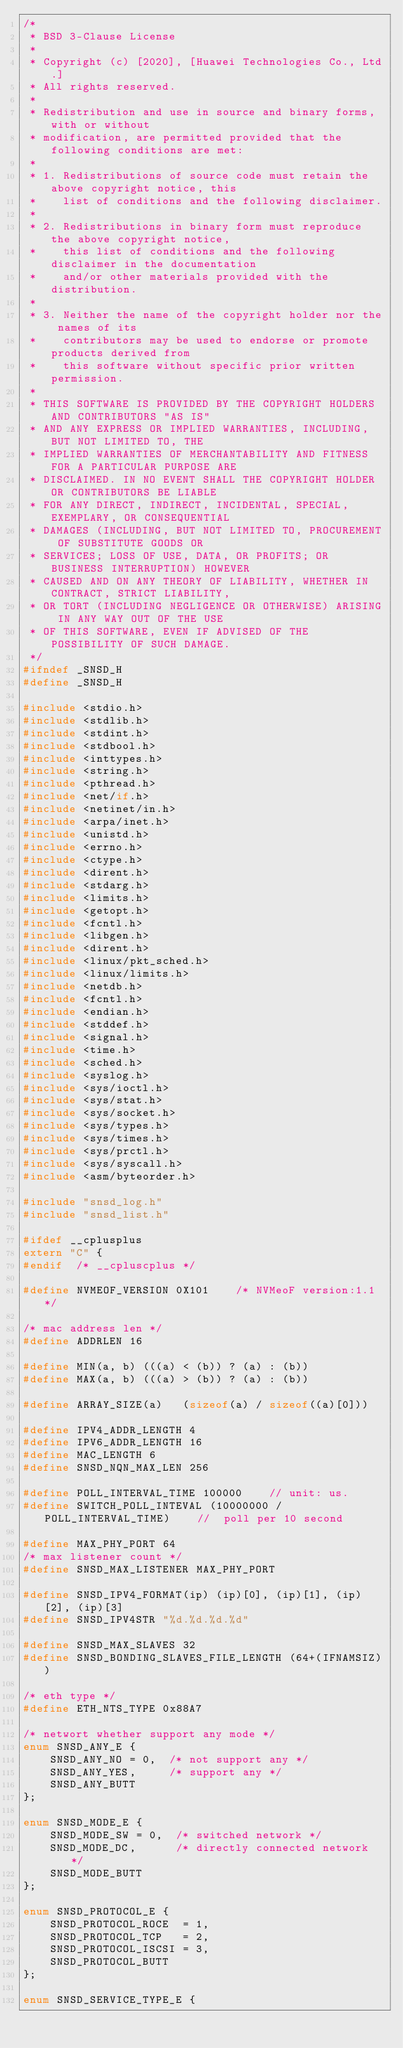<code> <loc_0><loc_0><loc_500><loc_500><_C_>/*
 * BSD 3-Clause License
 * 
 * Copyright (c) [2020], [Huawei Technologies Co., Ltd.]
 * All rights reserved.
 * 
 * Redistribution and use in source and binary forms, with or without
 * modification, are permitted provided that the following conditions are met:
 * 
 * 1. Redistributions of source code must retain the above copyright notice, this
 *    list of conditions and the following disclaimer.
 * 
 * 2. Redistributions in binary form must reproduce the above copyright notice,
 *    this list of conditions and the following disclaimer in the documentation
 *    and/or other materials provided with the distribution.
 * 
 * 3. Neither the name of the copyright holder nor the names of its
 *    contributors may be used to endorse or promote products derived from
 *    this software without specific prior written permission.
 *
 * THIS SOFTWARE IS PROVIDED BY THE COPYRIGHT HOLDERS AND CONTRIBUTORS "AS IS"
 * AND ANY EXPRESS OR IMPLIED WARRANTIES, INCLUDING, BUT NOT LIMITED TO, THE
 * IMPLIED WARRANTIES OF MERCHANTABILITY AND FITNESS FOR A PARTICULAR PURPOSE ARE
 * DISCLAIMED. IN NO EVENT SHALL THE COPYRIGHT HOLDER OR CONTRIBUTORS BE LIABLE
 * FOR ANY DIRECT, INDIRECT, INCIDENTAL, SPECIAL, EXEMPLARY, OR CONSEQUENTIAL
 * DAMAGES (INCLUDING, BUT NOT LIMITED TO, PROCUREMENT OF SUBSTITUTE GOODS OR
 * SERVICES; LOSS OF USE, DATA, OR PROFITS; OR BUSINESS INTERRUPTION) HOWEVER
 * CAUSED AND ON ANY THEORY OF LIABILITY, WHETHER IN CONTRACT, STRICT LIABILITY,
 * OR TORT (INCLUDING NEGLIGENCE OR OTHERWISE) ARISING IN ANY WAY OUT OF THE USE
 * OF THIS SOFTWARE, EVEN IF ADVISED OF THE POSSIBILITY OF SUCH DAMAGE.
 */
#ifndef _SNSD_H
#define _SNSD_H

#include <stdio.h>
#include <stdlib.h>
#include <stdint.h>
#include <stdbool.h>
#include <inttypes.h>
#include <string.h>
#include <pthread.h>
#include <net/if.h>  
#include <netinet/in.h>
#include <arpa/inet.h>
#include <unistd.h>
#include <errno.h>
#include <ctype.h>
#include <dirent.h>
#include <stdarg.h>
#include <limits.h>
#include <getopt.h>
#include <fcntl.h>
#include <libgen.h>
#include <dirent.h>
#include <linux/pkt_sched.h>
#include <linux/limits.h>
#include <netdb.h>
#include <fcntl.h>
#include <endian.h>
#include <stddef.h>
#include <signal.h>
#include <time.h>
#include <sched.h>
#include <syslog.h>
#include <sys/ioctl.h>
#include <sys/stat.h>
#include <sys/socket.h>
#include <sys/types.h>
#include <sys/times.h>
#include <sys/prctl.h>
#include <sys/syscall.h>
#include <asm/byteorder.h>

#include "snsd_log.h"
#include "snsd_list.h"

#ifdef __cplusplus
extern "C" {
#endif  /* __cpluscplus */

#define NVMEOF_VERSION 0X101    /* NVMeoF version:1.1 */

/* mac address len */
#define ADDRLEN 16

#define MIN(a, b) (((a) < (b)) ? (a) : (b))
#define MAX(a, b) (((a) > (b)) ? (a) : (b))

#define ARRAY_SIZE(a)   (sizeof(a) / sizeof((a)[0]))

#define IPV4_ADDR_LENGTH 4
#define IPV6_ADDR_LENGTH 16
#define MAC_LENGTH 6
#define SNSD_NQN_MAX_LEN 256

#define POLL_INTERVAL_TIME 100000    // unit: us.
#define SWITCH_POLL_INTEVAL (10000000 / POLL_INTERVAL_TIME)    //  poll per 10 second

#define MAX_PHY_PORT 64
/* max listener count */
#define SNSD_MAX_LISTENER MAX_PHY_PORT

#define SNSD_IPV4_FORMAT(ip) (ip)[0], (ip)[1], (ip)[2], (ip)[3]
#define SNSD_IPV4STR "%d.%d.%d.%d"

#define SNSD_MAX_SLAVES 32
#define SNSD_BONDING_SLAVES_FILE_LENGTH (64+(IFNAMSIZ))

/* eth type */
#define ETH_NTS_TYPE 0x88A7

/* networt whether support any mode */
enum SNSD_ANY_E {   
    SNSD_ANY_NO = 0,  /* not support any */
    SNSD_ANY_YES,     /* support any */
    SNSD_ANY_BUTT
};

enum SNSD_MODE_E {   
    SNSD_MODE_SW = 0,  /* switched network */
    SNSD_MODE_DC,      /* directly connected network */
    SNSD_MODE_BUTT
};

enum SNSD_PROTOCOL_E {   
    SNSD_PROTOCOL_ROCE  = 1,
    SNSD_PROTOCOL_TCP   = 2,
    SNSD_PROTOCOL_ISCSI = 3,
    SNSD_PROTOCOL_BUTT
};

enum SNSD_SERVICE_TYPE_E {   </code> 